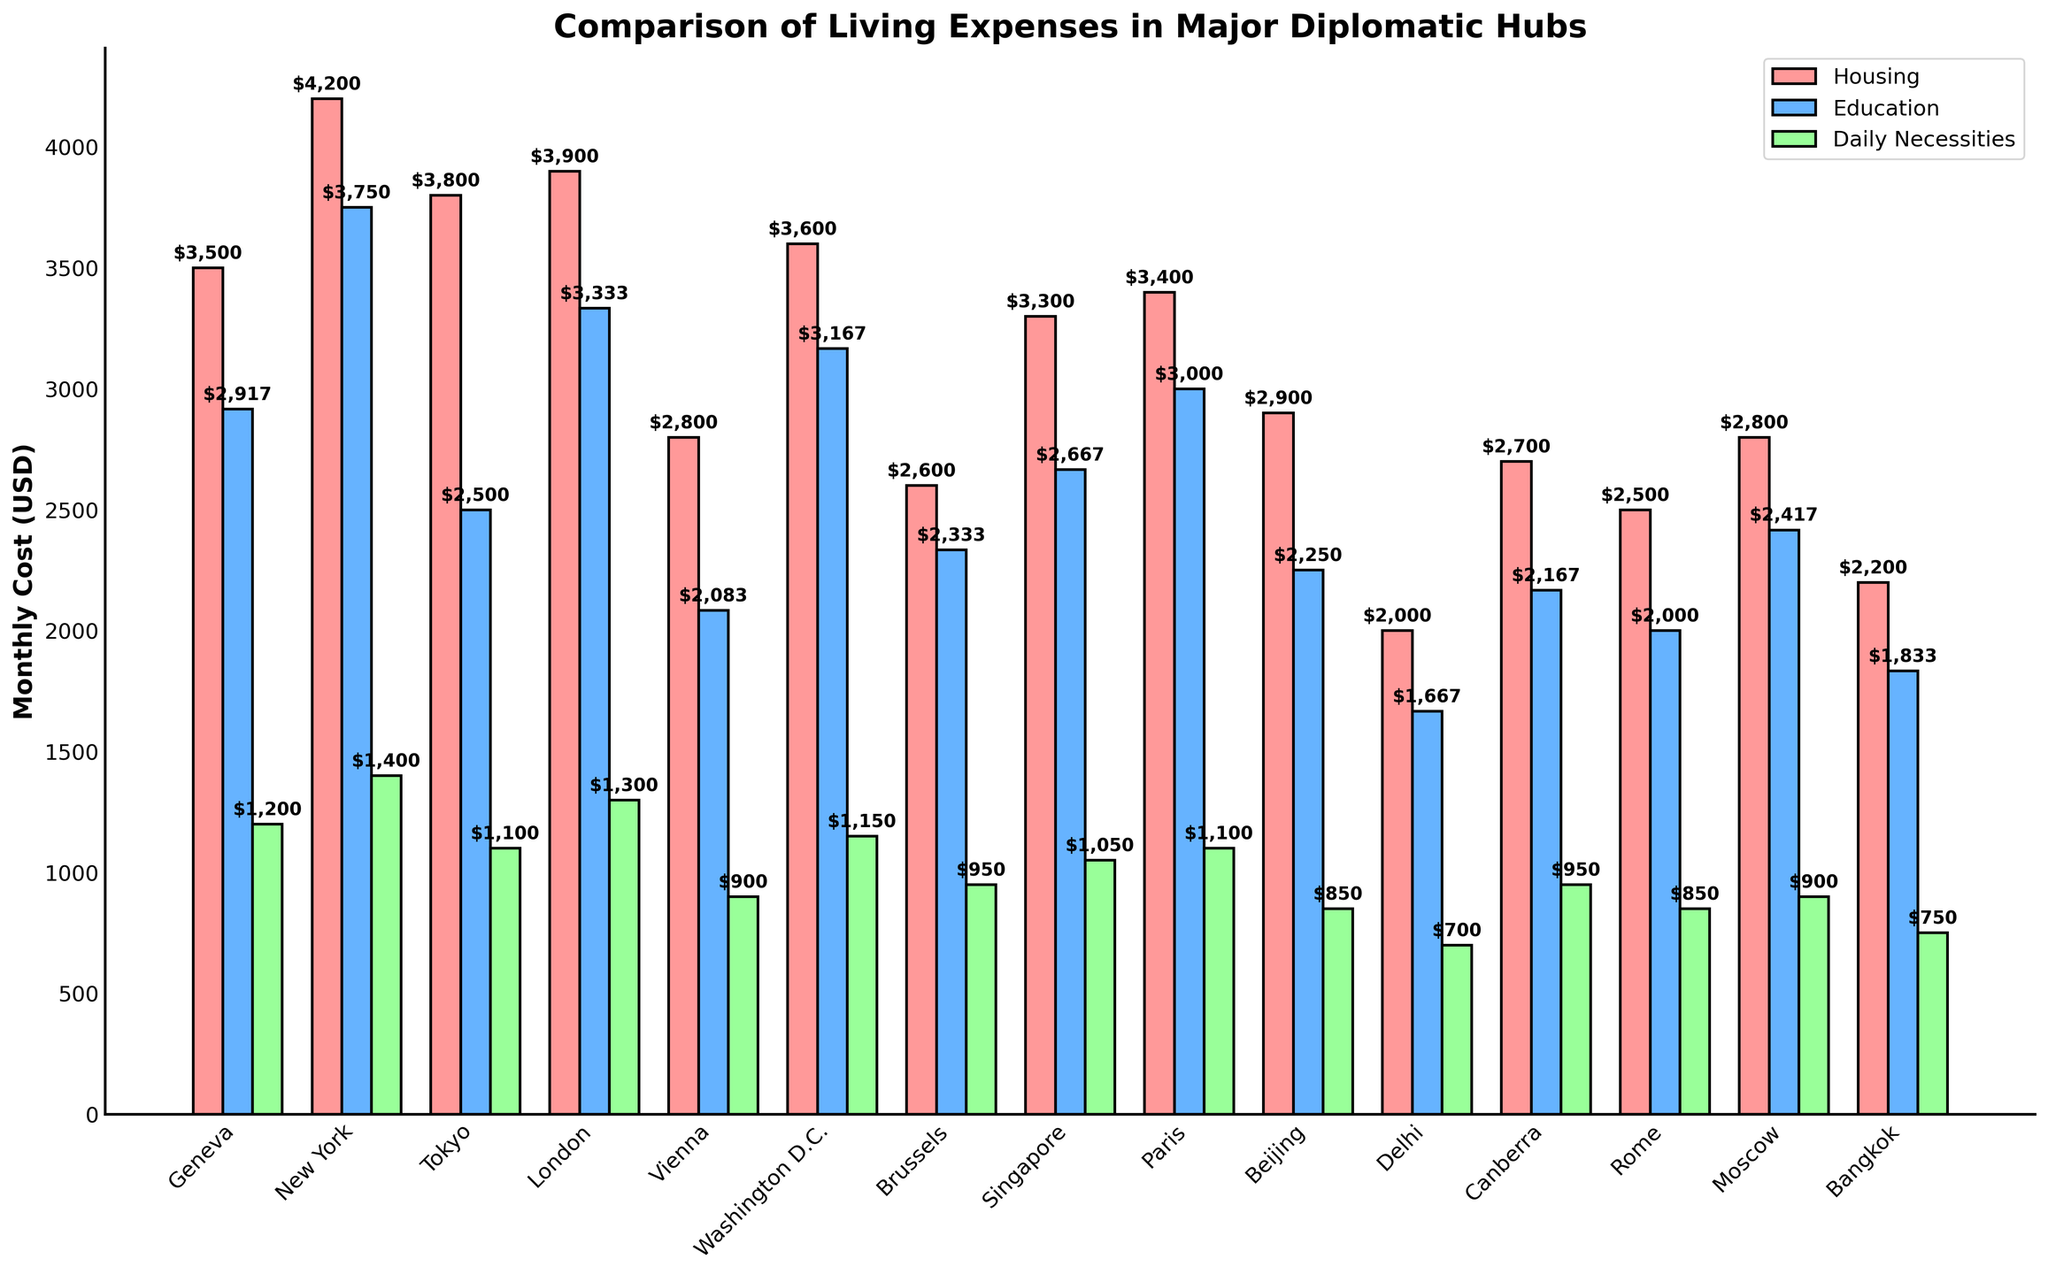Which city has the highest monthly housing cost? By looking at the height of the red bars designated for housing costs, New York has the highest bar, indicating the highest monthly housing cost.
Answer: New York Which city has the lowest monthly daily necessities cost? By examining the height of the green bars representing daily necessities, Delhi has the shortest bar, indicating the lowest monthly daily necessities cost.
Answer: Delhi What is the difference in monthly housing cost between Geneva and Delhi? Geneva's housing cost is $3500/month, and Delhi's is $2000/month. The difference is $3500 - $2000 = $1500.
Answer: $1500 In which city does education cost the most on a monthly basis, and how much is it? By converting the annual education costs to a monthly cost and comparing the blue bars, New York has the highest bar with education costing $45000/year, which equals $45000/12 = $3750/month.
Answer: New York, $3750 Which city has the overall highest monthly living expenses when considering housing, education, and daily necessities together? Adding the three expenses for each city, New York comes out highest: Housing ($4200) + Education ($3750) + Daily Necessities ($1400) = $9350/month.
Answer: New York What is the combined monthly cost for housing and daily necessities in Washington D.C.? Housing in Washington D.C. costs $3600/month, and daily necessities cost $1150/month. Combined, it is $3600 + $1150 = $4750.
Answer: $4750 How much more does housing cost in Vienna compared to Rome? Housing cost in Vienna is $2800/month, while in Rome, it is $2500/month. The difference is $2800 - $2500 = $300.
Answer: $300 Which city has the highest education cost after New York, and how much is it? Looking at the blue bars, London follows New York with its annual education cost of $40000/year, which equals $40000/12 ≈ $3333/month.
Answer: London, $3333 Among Geneva, Brussels, and Singapore, which city has the lowest monthly total of housing, education, and daily necessities costs, and what is the total? Adding up the costs for each city: 
Geneva: $3500 (Housing) + $2917 (Education) + $1200 (Daily Necessities) = $7617/month,
Brussels: $2600 (Housing) + $2333 (Education) + $950 (Daily Necessities) = $5883/month,
Singapore: $3300 (Housing) + $2667 (Education) + $1050 (Daily Necessities) = $7017/month.
Brussels has the lowest total monthly cost.
Answer: Brussels, $5883 Which city has the highest daily necessity cost and how much is it? By looking at the height of the green bars, New York has the highest bar for daily necessity costs, which is $1400/month.
Answer: New York, $1400 